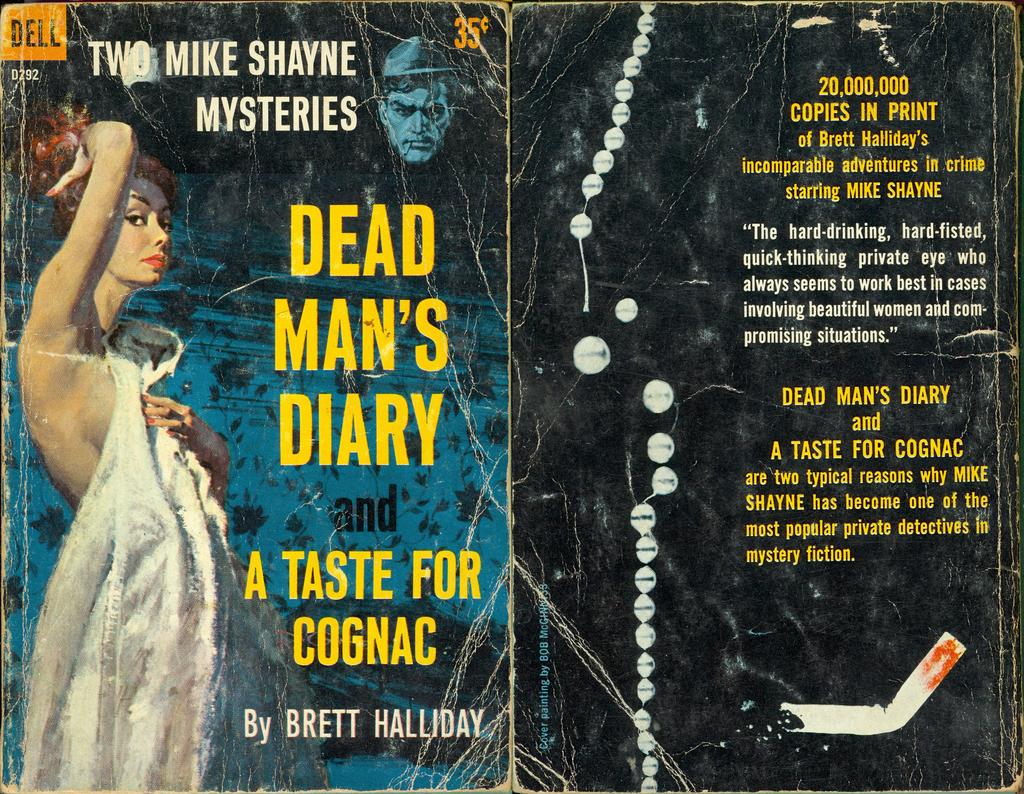Who is the author of the book?
Provide a short and direct response. Brett halliday. 